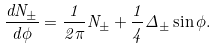Convert formula to latex. <formula><loc_0><loc_0><loc_500><loc_500>\frac { d N _ { \pm } } { d \phi } = \frac { 1 } { 2 \pi } N _ { \pm } + \frac { 1 } { 4 } \Delta _ { \pm } \sin \phi .</formula> 